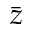Convert formula to latex. <formula><loc_0><loc_0><loc_500><loc_500>\bar { z }</formula> 